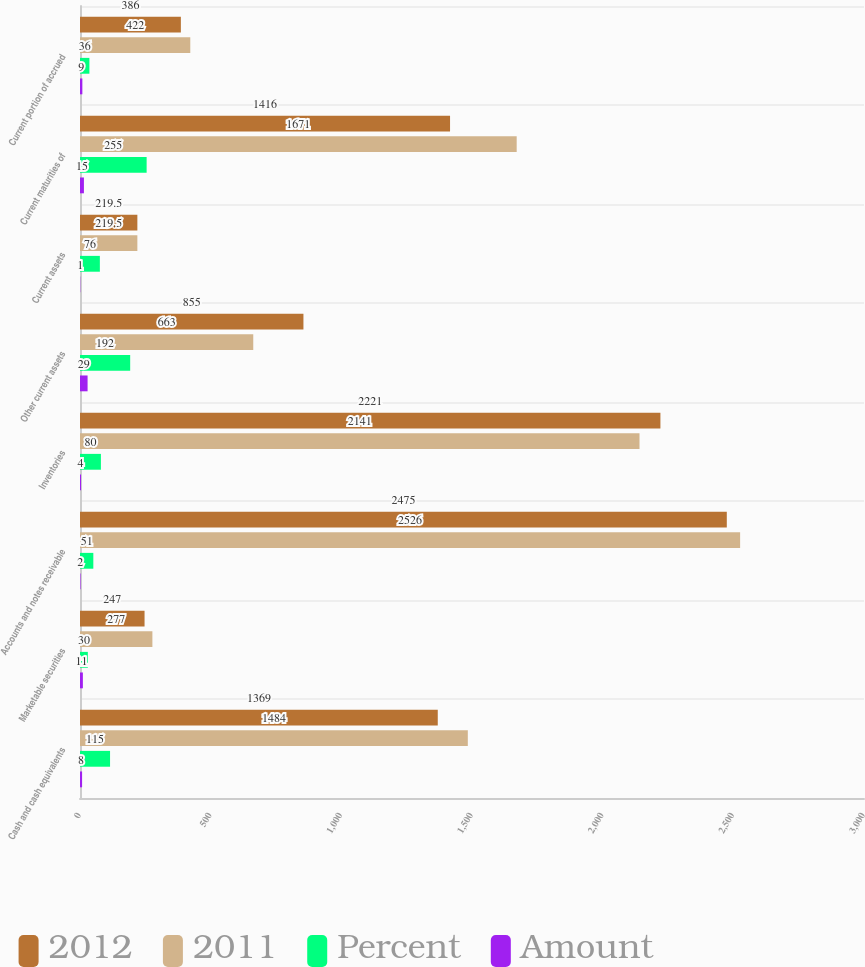Convert chart. <chart><loc_0><loc_0><loc_500><loc_500><stacked_bar_chart><ecel><fcel>Cash and cash equivalents<fcel>Marketable securities<fcel>Accounts and notes receivable<fcel>Inventories<fcel>Other current assets<fcel>Current assets<fcel>Current maturities of<fcel>Current portion of accrued<nl><fcel>2012<fcel>1369<fcel>247<fcel>2475<fcel>2221<fcel>855<fcel>219.5<fcel>1416<fcel>386<nl><fcel>2011<fcel>1484<fcel>277<fcel>2526<fcel>2141<fcel>663<fcel>219.5<fcel>1671<fcel>422<nl><fcel>Percent<fcel>115<fcel>30<fcel>51<fcel>80<fcel>192<fcel>76<fcel>255<fcel>36<nl><fcel>Amount<fcel>8<fcel>11<fcel>2<fcel>4<fcel>29<fcel>1<fcel>15<fcel>9<nl></chart> 